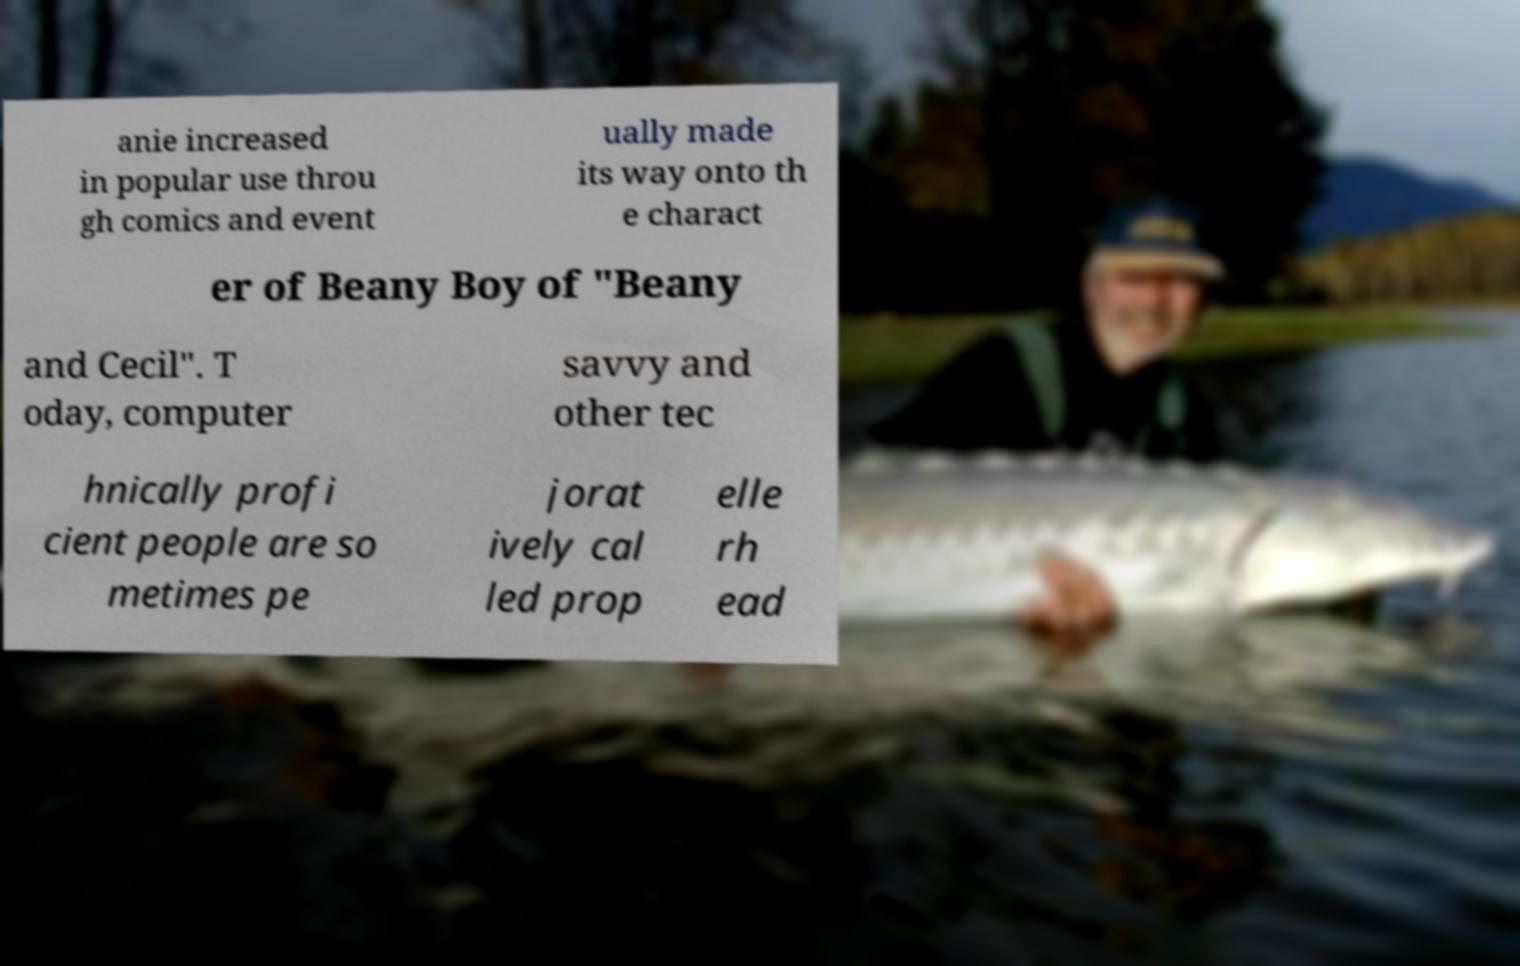I need the written content from this picture converted into text. Can you do that? anie increased in popular use throu gh comics and event ually made its way onto th e charact er of Beany Boy of "Beany and Cecil". T oday, computer savvy and other tec hnically profi cient people are so metimes pe jorat ively cal led prop elle rh ead 